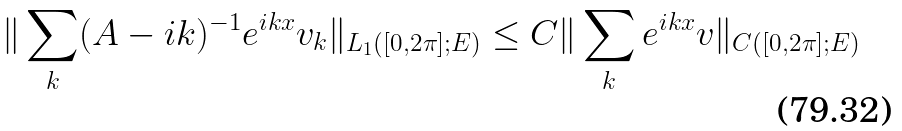<formula> <loc_0><loc_0><loc_500><loc_500>\| \sum _ { k } ( A - i k ) ^ { - 1 } e ^ { i k x } v _ { k } \| _ { L _ { 1 } ( [ 0 , 2 \pi ] ; E ) } \leq C \| \sum _ { k } e ^ { i k x } v \| _ { C ( [ 0 , 2 \pi ] ; E ) }</formula> 